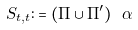<formula> <loc_0><loc_0><loc_500><loc_500>S _ { t , t } \colon = ( \Pi \cup \Pi ^ { \prime } ) \ \alpha</formula> 